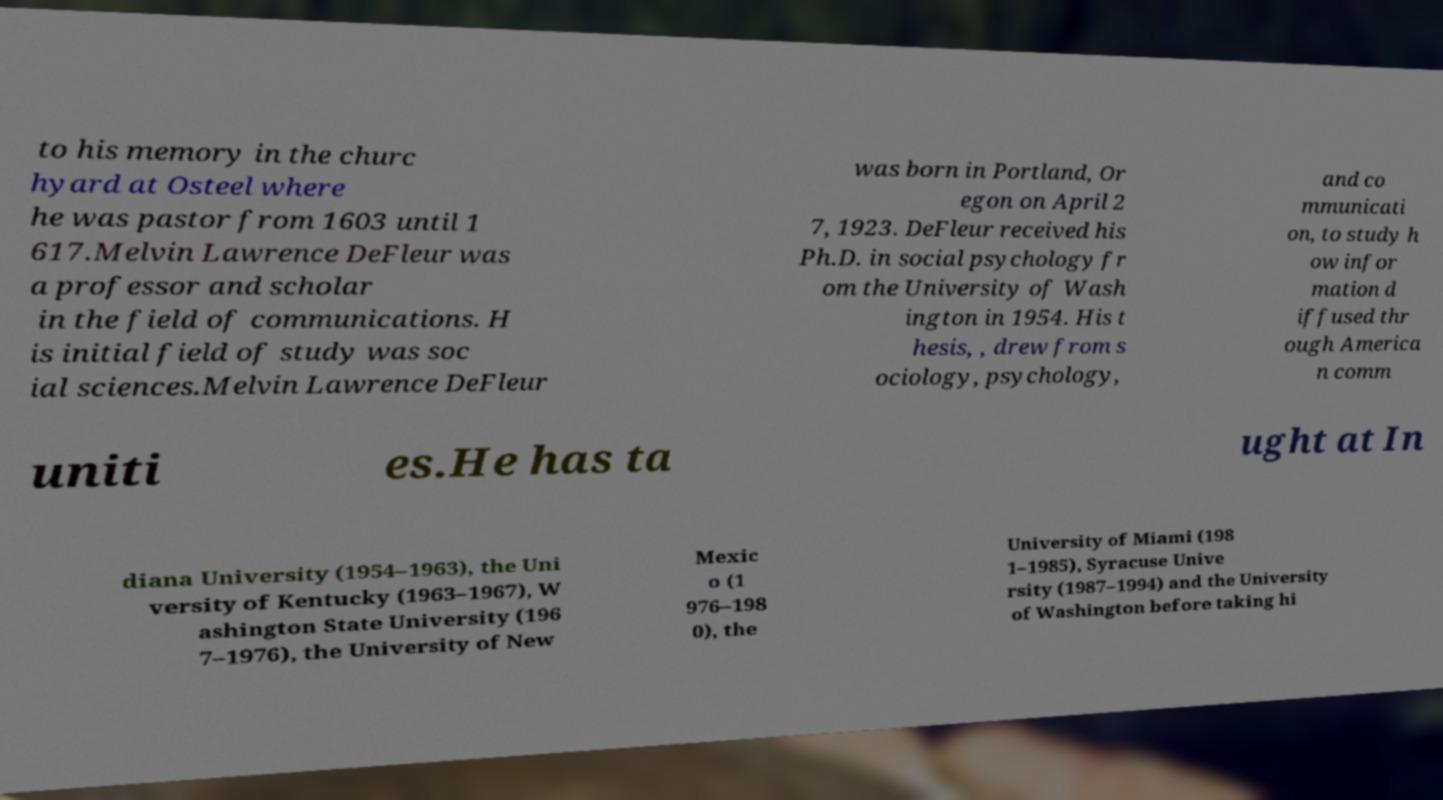Can you read and provide the text displayed in the image?This photo seems to have some interesting text. Can you extract and type it out for me? to his memory in the churc hyard at Osteel where he was pastor from 1603 until 1 617.Melvin Lawrence DeFleur was a professor and scholar in the field of communications. H is initial field of study was soc ial sciences.Melvin Lawrence DeFleur was born in Portland, Or egon on April 2 7, 1923. DeFleur received his Ph.D. in social psychology fr om the University of Wash ington in 1954. His t hesis, , drew from s ociology, psychology, and co mmunicati on, to study h ow infor mation d iffused thr ough America n comm uniti es.He has ta ught at In diana University (1954–1963), the Uni versity of Kentucky (1963–1967), W ashington State University (196 7–1976), the University of New Mexic o (1 976–198 0), the University of Miami (198 1–1985), Syracuse Unive rsity (1987–1994) and the University of Washington before taking hi 